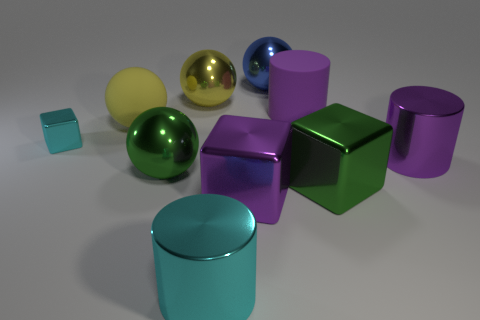How many purple cylinders must be subtracted to get 1 purple cylinders? 1 Subtract all big metallic balls. How many balls are left? 1 Subtract all cyan cylinders. How many cylinders are left? 2 Subtract all cylinders. How many objects are left? 7 Subtract 1 spheres. How many spheres are left? 3 Add 9 big blue metal things. How many big blue metal things are left? 10 Add 8 blue matte cylinders. How many blue matte cylinders exist? 8 Subtract 0 gray balls. How many objects are left? 10 Subtract all yellow cubes. Subtract all brown cylinders. How many cubes are left? 3 Subtract all yellow cylinders. How many cyan cubes are left? 1 